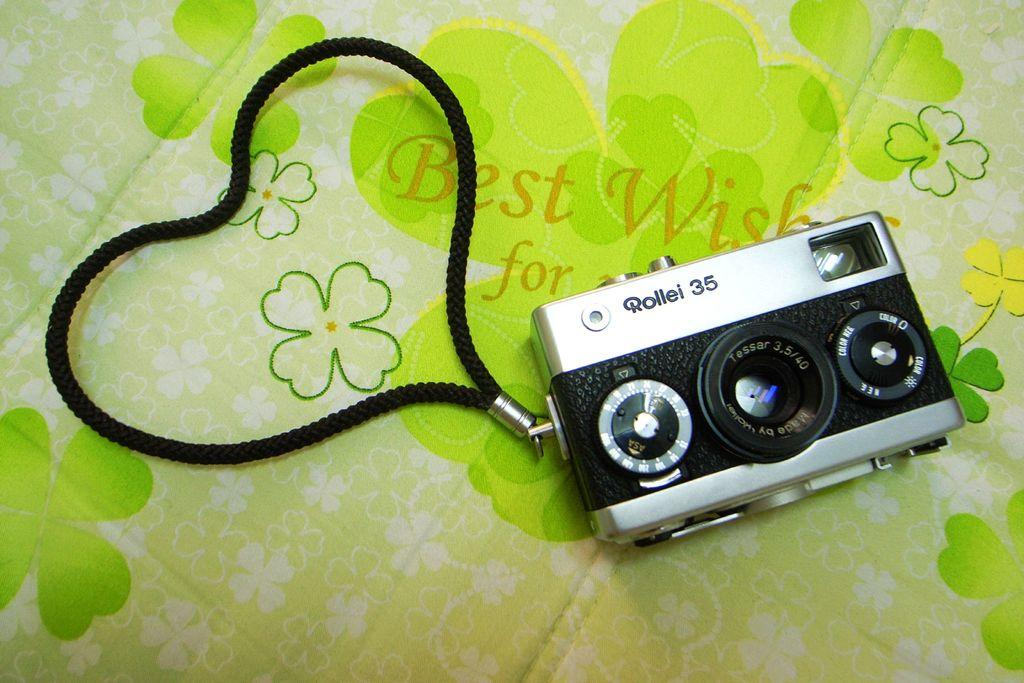<image>
Describe the image concisely. Rollei 35 camera that is black and silver with a black string attached 